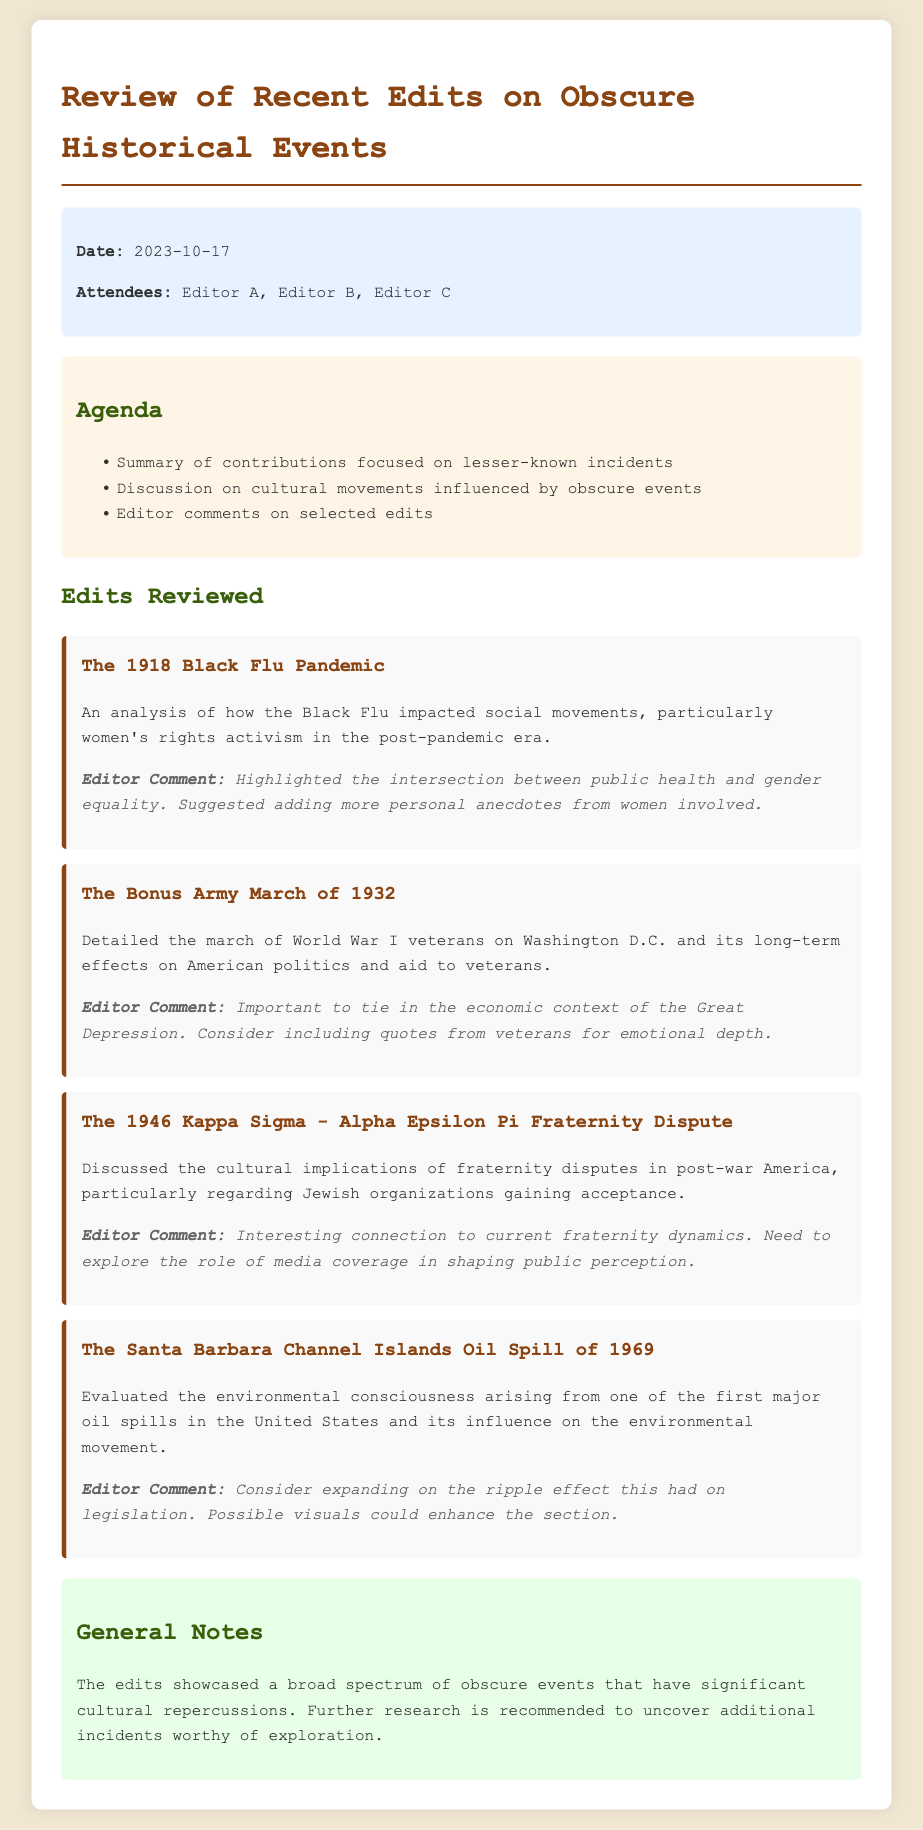what was the date of the meeting? The date is mentioned in the meta-info section of the document.
Answer: 2023-10-17 who are the attendees of the meeting? The names of the attendees are listed in the meta-info section.
Answer: Editor A, Editor B, Editor C what is one of the main topics discussed in the agenda? The agenda outlines key discussion points focusing on contributions and cultural movements.
Answer: Discussion on cultural movements influenced by obscure events which event discussed relates to women's rights activism? The specific event is described in the edits reviewed section and highlights societal impacts.
Answer: The 1918 Black Flu Pandemic what suggestion was made regarding the 1969 oil spill? The editor comment provides insights into potential improvements for the section.
Answer: Consider expanding on the ripple effect this had on legislation what is the cultural significance of the 1946 Kappa Sigma - Alpha Epsilon Pi Fraternity Dispute? The document highlights how this incident relates to Jewish organizations and public perception.
Answer: Cultural implications of fraternity disputes in post-war America what additional research is recommended in the general notes? The general notes summarize recommendations for future explorations of events.
Answer: Further research is recommended to uncover additional incidents worthy of exploration 